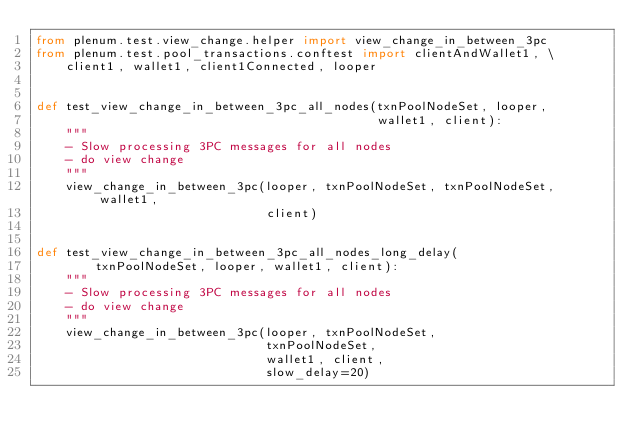<code> <loc_0><loc_0><loc_500><loc_500><_Python_>from plenum.test.view_change.helper import view_change_in_between_3pc
from plenum.test.pool_transactions.conftest import clientAndWallet1, \
    client1, wallet1, client1Connected, looper


def test_view_change_in_between_3pc_all_nodes(txnPoolNodeSet, looper,
                                              wallet1, client):
    """
    - Slow processing 3PC messages for all nodes
    - do view change
    """
    view_change_in_between_3pc(looper, txnPoolNodeSet, txnPoolNodeSet, wallet1,
                               client)


def test_view_change_in_between_3pc_all_nodes_long_delay(
        txnPoolNodeSet, looper, wallet1, client):
    """
    - Slow processing 3PC messages for all nodes
    - do view change
    """
    view_change_in_between_3pc(looper, txnPoolNodeSet,
                               txnPoolNodeSet,
                               wallet1, client,
                               slow_delay=20)
</code> 